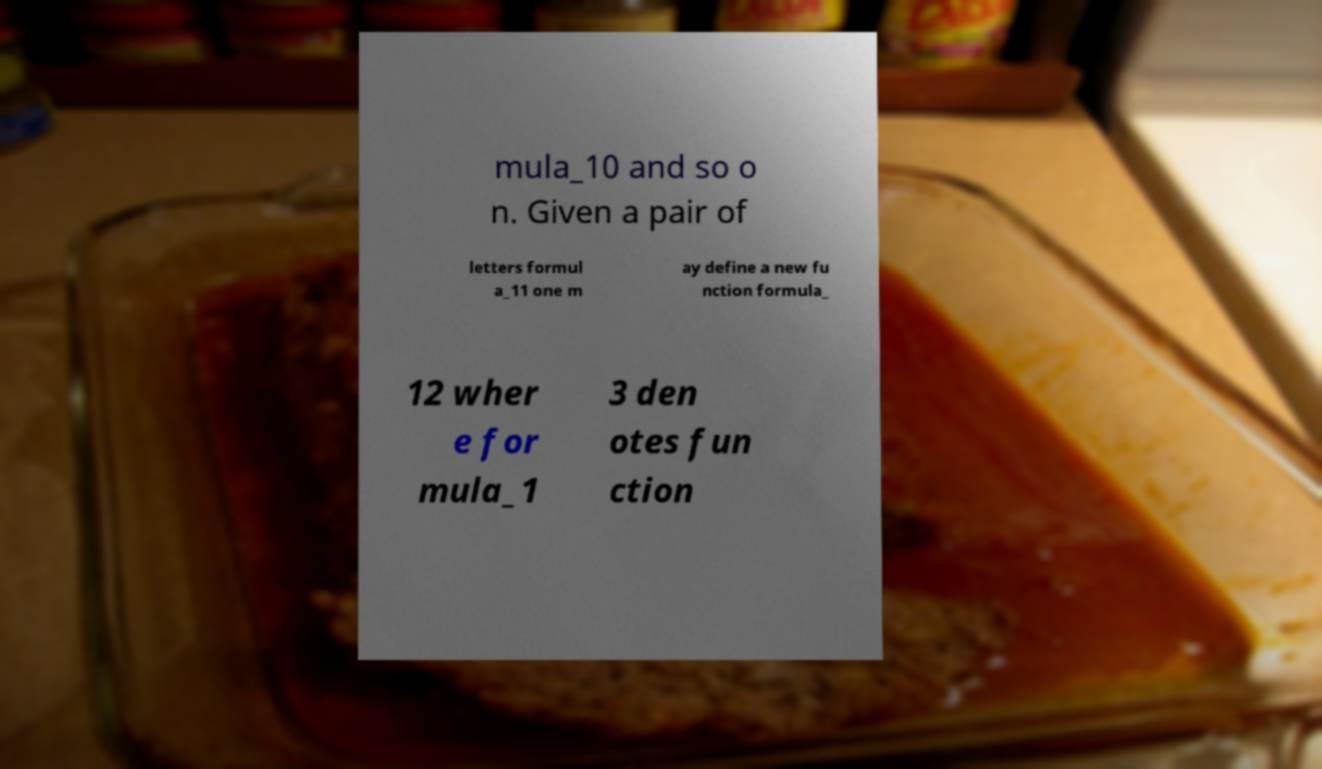There's text embedded in this image that I need extracted. Can you transcribe it verbatim? mula_10 and so o n. Given a pair of letters formul a_11 one m ay define a new fu nction formula_ 12 wher e for mula_1 3 den otes fun ction 